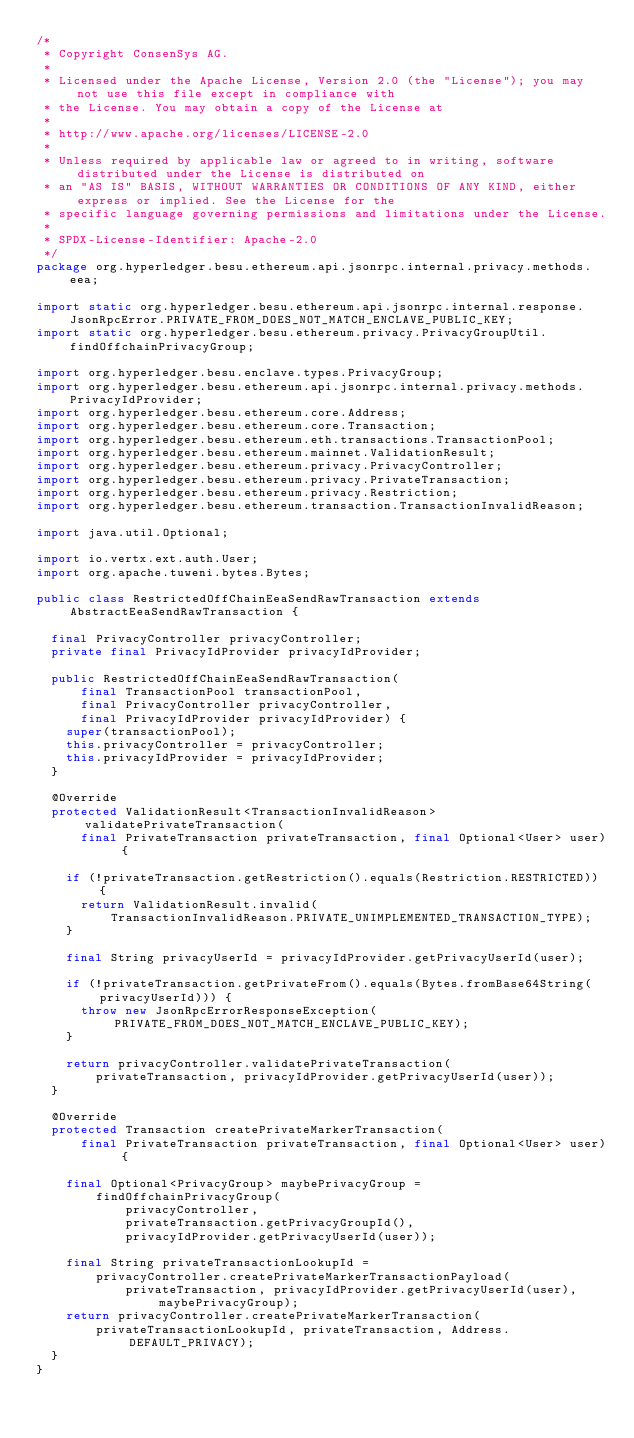Convert code to text. <code><loc_0><loc_0><loc_500><loc_500><_Java_>/*
 * Copyright ConsenSys AG.
 *
 * Licensed under the Apache License, Version 2.0 (the "License"); you may not use this file except in compliance with
 * the License. You may obtain a copy of the License at
 *
 * http://www.apache.org/licenses/LICENSE-2.0
 *
 * Unless required by applicable law or agreed to in writing, software distributed under the License is distributed on
 * an "AS IS" BASIS, WITHOUT WARRANTIES OR CONDITIONS OF ANY KIND, either express or implied. See the License for the
 * specific language governing permissions and limitations under the License.
 *
 * SPDX-License-Identifier: Apache-2.0
 */
package org.hyperledger.besu.ethereum.api.jsonrpc.internal.privacy.methods.eea;

import static org.hyperledger.besu.ethereum.api.jsonrpc.internal.response.JsonRpcError.PRIVATE_FROM_DOES_NOT_MATCH_ENCLAVE_PUBLIC_KEY;
import static org.hyperledger.besu.ethereum.privacy.PrivacyGroupUtil.findOffchainPrivacyGroup;

import org.hyperledger.besu.enclave.types.PrivacyGroup;
import org.hyperledger.besu.ethereum.api.jsonrpc.internal.privacy.methods.PrivacyIdProvider;
import org.hyperledger.besu.ethereum.core.Address;
import org.hyperledger.besu.ethereum.core.Transaction;
import org.hyperledger.besu.ethereum.eth.transactions.TransactionPool;
import org.hyperledger.besu.ethereum.mainnet.ValidationResult;
import org.hyperledger.besu.ethereum.privacy.PrivacyController;
import org.hyperledger.besu.ethereum.privacy.PrivateTransaction;
import org.hyperledger.besu.ethereum.privacy.Restriction;
import org.hyperledger.besu.ethereum.transaction.TransactionInvalidReason;

import java.util.Optional;

import io.vertx.ext.auth.User;
import org.apache.tuweni.bytes.Bytes;

public class RestrictedOffChainEeaSendRawTransaction extends AbstractEeaSendRawTransaction {

  final PrivacyController privacyController;
  private final PrivacyIdProvider privacyIdProvider;

  public RestrictedOffChainEeaSendRawTransaction(
      final TransactionPool transactionPool,
      final PrivacyController privacyController,
      final PrivacyIdProvider privacyIdProvider) {
    super(transactionPool);
    this.privacyController = privacyController;
    this.privacyIdProvider = privacyIdProvider;
  }

  @Override
  protected ValidationResult<TransactionInvalidReason> validatePrivateTransaction(
      final PrivateTransaction privateTransaction, final Optional<User> user) {

    if (!privateTransaction.getRestriction().equals(Restriction.RESTRICTED)) {
      return ValidationResult.invalid(
          TransactionInvalidReason.PRIVATE_UNIMPLEMENTED_TRANSACTION_TYPE);
    }

    final String privacyUserId = privacyIdProvider.getPrivacyUserId(user);

    if (!privateTransaction.getPrivateFrom().equals(Bytes.fromBase64String(privacyUserId))) {
      throw new JsonRpcErrorResponseException(PRIVATE_FROM_DOES_NOT_MATCH_ENCLAVE_PUBLIC_KEY);
    }

    return privacyController.validatePrivateTransaction(
        privateTransaction, privacyIdProvider.getPrivacyUserId(user));
  }

  @Override
  protected Transaction createPrivateMarkerTransaction(
      final PrivateTransaction privateTransaction, final Optional<User> user) {

    final Optional<PrivacyGroup> maybePrivacyGroup =
        findOffchainPrivacyGroup(
            privacyController,
            privateTransaction.getPrivacyGroupId(),
            privacyIdProvider.getPrivacyUserId(user));

    final String privateTransactionLookupId =
        privacyController.createPrivateMarkerTransactionPayload(
            privateTransaction, privacyIdProvider.getPrivacyUserId(user), maybePrivacyGroup);
    return privacyController.createPrivateMarkerTransaction(
        privateTransactionLookupId, privateTransaction, Address.DEFAULT_PRIVACY);
  }
}
</code> 